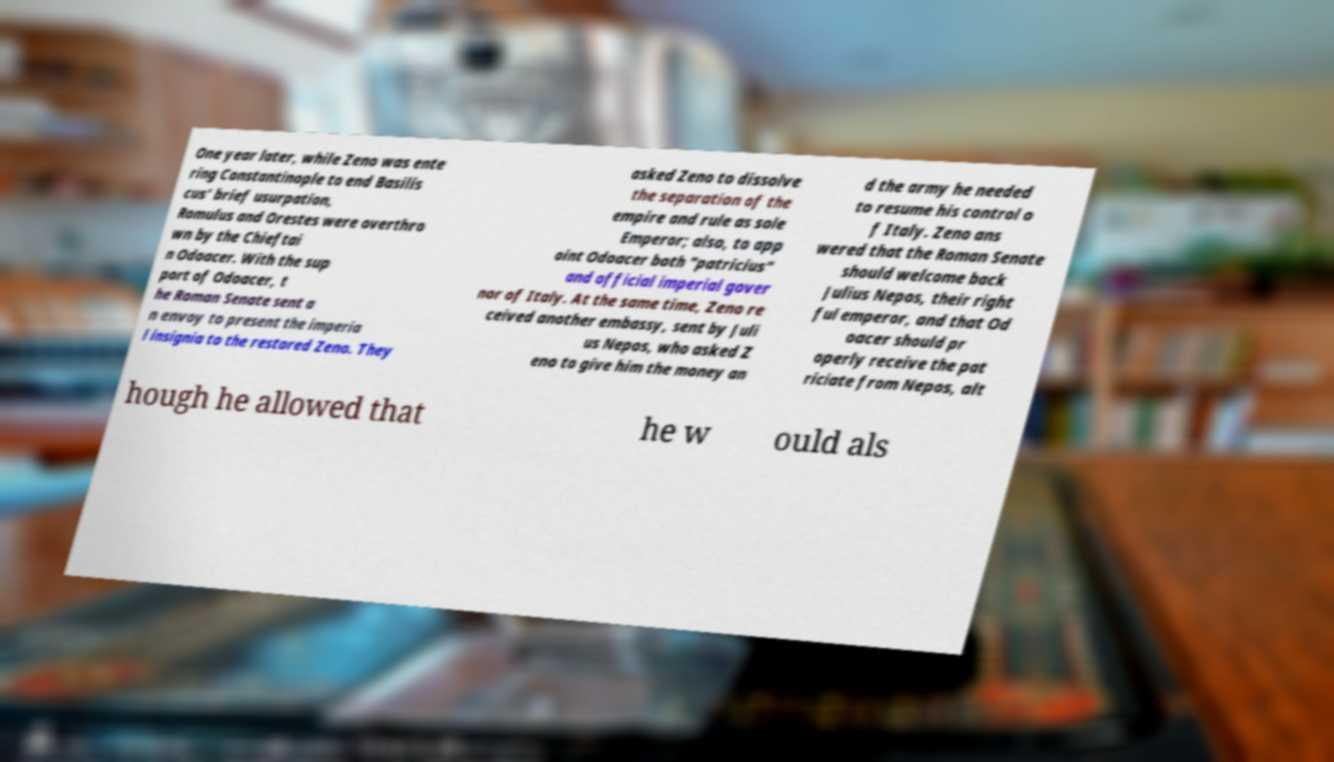Can you read and provide the text displayed in the image?This photo seems to have some interesting text. Can you extract and type it out for me? One year later, while Zeno was ente ring Constantinople to end Basilis cus' brief usurpation, Romulus and Orestes were overthro wn by the Chieftai n Odoacer. With the sup port of Odoacer, t he Roman Senate sent a n envoy to present the imperia l insignia to the restored Zeno. They asked Zeno to dissolve the separation of the empire and rule as sole Emperor; also, to app oint Odoacer both "patricius" and official imperial gover nor of Italy. At the same time, Zeno re ceived another embassy, sent by Juli us Nepos, who asked Z eno to give him the money an d the army he needed to resume his control o f Italy. Zeno ans wered that the Roman Senate should welcome back Julius Nepos, their right ful emperor, and that Od oacer should pr operly receive the pat riciate from Nepos, alt hough he allowed that he w ould als 